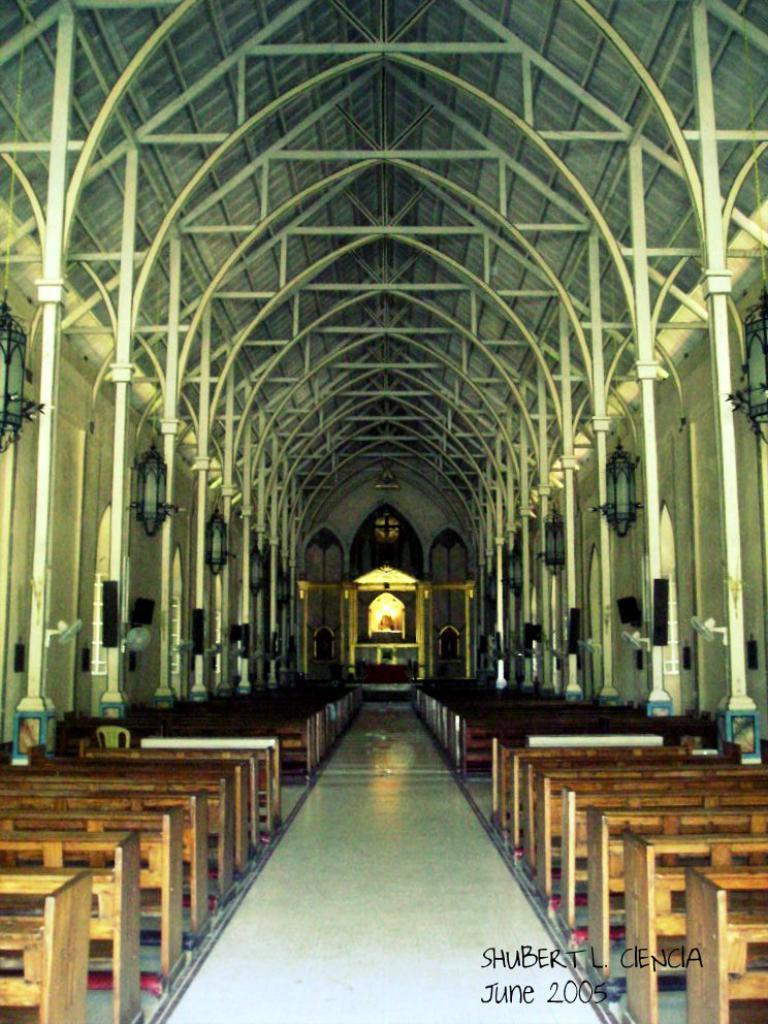<image>
Provide a brief description of the given image. A narrow but very long church has many pews that sit below archways in June 2005 